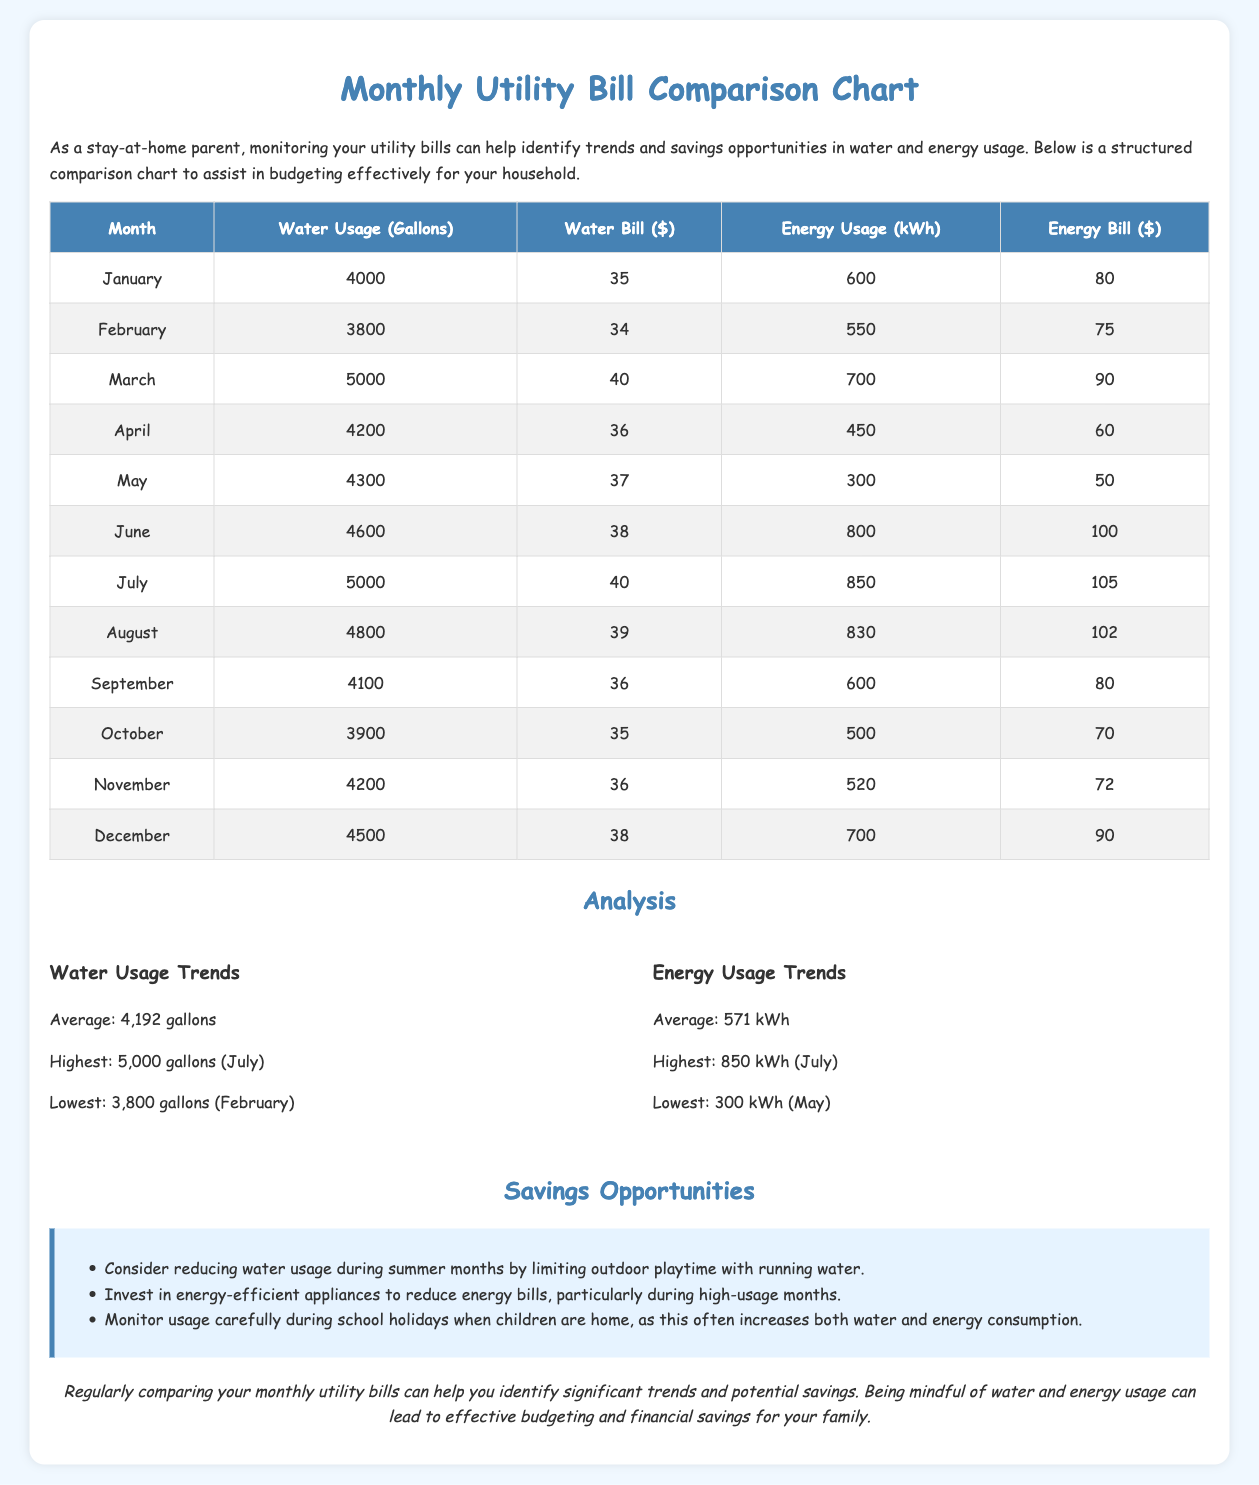What is the water bill for July? The water bill for July is listed in the table under that month, which is $40.
Answer: $40 What month has the highest energy usage? The month with the highest energy usage can be found in the energy usage trends section, which shows July with 850 kWh.
Answer: July What is the lowest water usage recorded? The lowest water usage is given in the analysis section, showing February with 3,800 gallons.
Answer: 3,800 gallons What is the average energy bill for the months listed? The average energy bill is calculated from the values in the energy bill column and mentioned in the analysis section, which is $78.
Answer: $78 What savings opportunity suggests limiting water usage? The savings opportunity listed indicates reducing water usage during summer months to save on bills.
Answer: Limiting outdoor playtime with running water What is the energy bill for March? The energy bill for March can be found in the table for that month, which is $90.
Answer: $90 What is the average water usage across all months? The average water usage is provided in the analysis section, which is 4,192 gallons.
Answer: 4,192 gallons What month had the lowest energy usage and how much was it? The month with the lowest energy usage is identified in the trends section, which is May with 300 kWh.
Answer: 300 kWh 